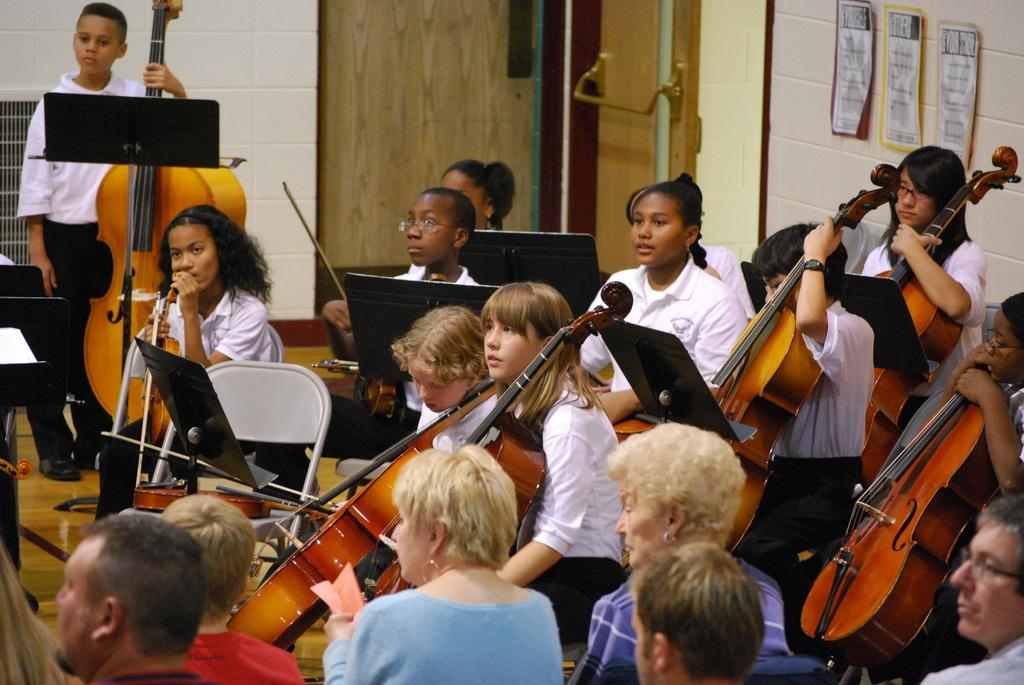What is the main subject of the image? The main subject of the image is a group of children. What are the children doing in the image? The children are sitting in chairs and have musical instruments. Are there any other people in the image besides the children? Yes, some people are watching the children. How are the people watching the children positioned in relation to them? The people watching are sitting beside the children. What type of match is being played in the image? There is no match being played in the image; it features a group of children with musical instruments and people watching them. Can you see a gate in the image? There is no gate visible in the image. 